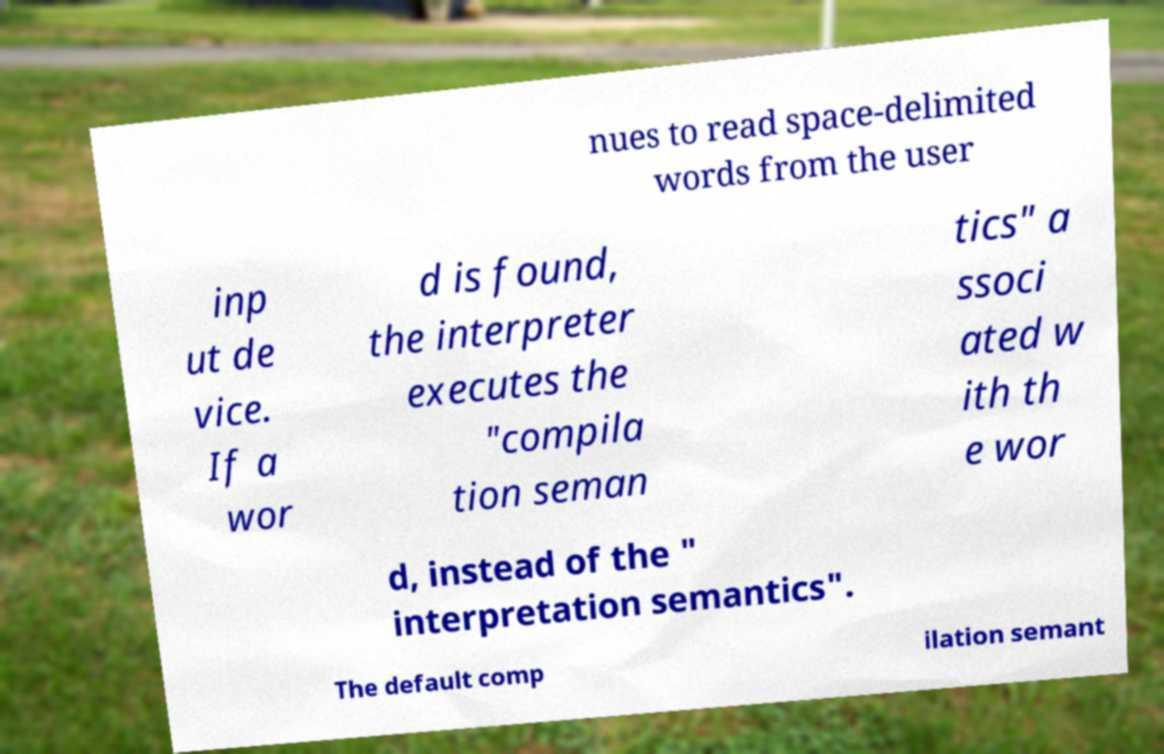Please identify and transcribe the text found in this image. nues to read space-delimited words from the user inp ut de vice. If a wor d is found, the interpreter executes the "compila tion seman tics" a ssoci ated w ith th e wor d, instead of the " interpretation semantics". The default comp ilation semant 